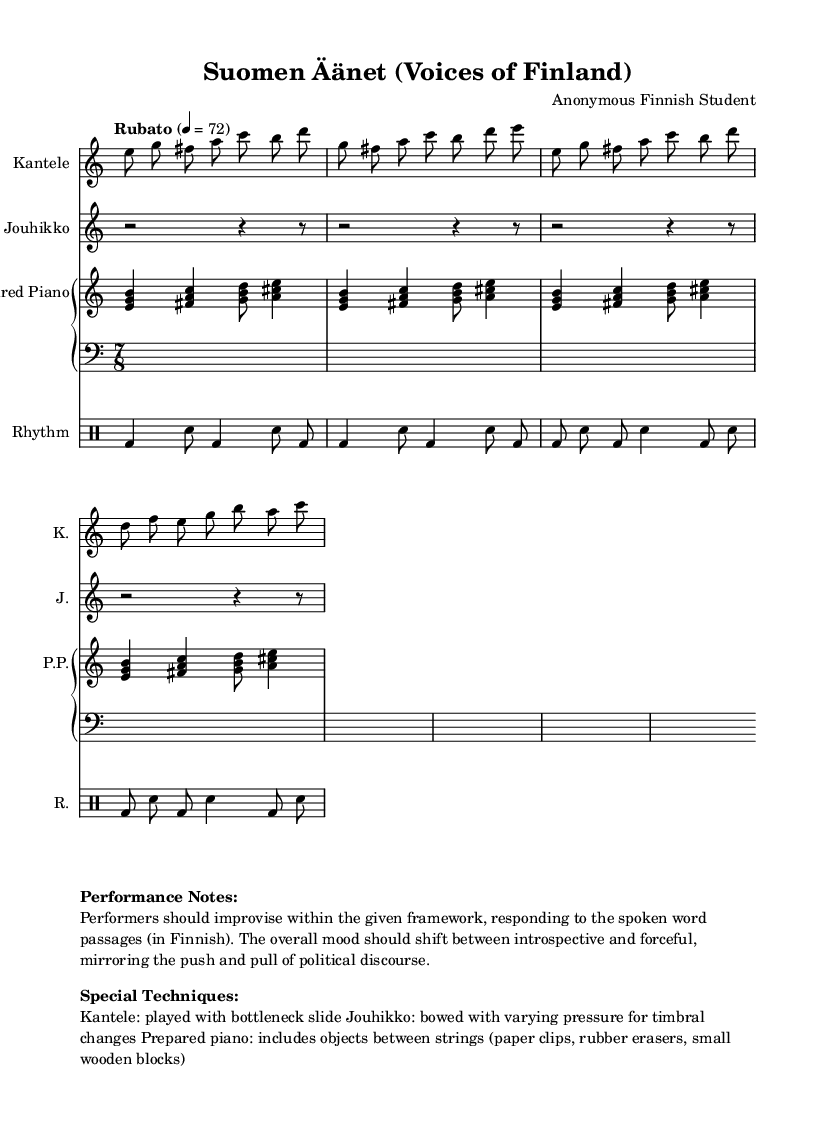What is the time signature of this music? The time signature indicated at the beginning is 7/8, which shows that each measure contains seven eighth-note beats.
Answer: 7/8 What instruments are included in the score? The score includes Kantele, Jouhikko, Prepared Piano, and Rhythm (drums). This information is provided in the individual staff headings.
Answer: Kantele, Jouhikko, Prepared Piano, Rhythm How many measures are there for the Jouhikko? By counting the groups of rhythmic notations in the Jouhikko line, there are a total of four measures indicated.
Answer: 4 What is the tempo marking for the piece? The tempo marking located above the Kantele staff is "Rubato" and it indicates a flexible tempo, with a reference of 72 beats per minute.
Answer: Rubato What special performance technique is specified for the Kantele? The performance note states that the Kantele should be played with a bottleneck slide, which is a distinctive technique for creating a unique sound.
Answer: Bottleneck slide Is there a dynamic marking for the Prepared Piano? There are no specific dynamic markings indicated for the Prepared Piano in the score; it emphasizes the use of unconventional objects for sound.
Answer: No What type of atmosphere should the performance convey? The performance notes suggest that the atmosphere should alternate between introspective and forceful, mirroring political discourse, suggesting emotional depth in interpretation.
Answer: Introspective and forceful 